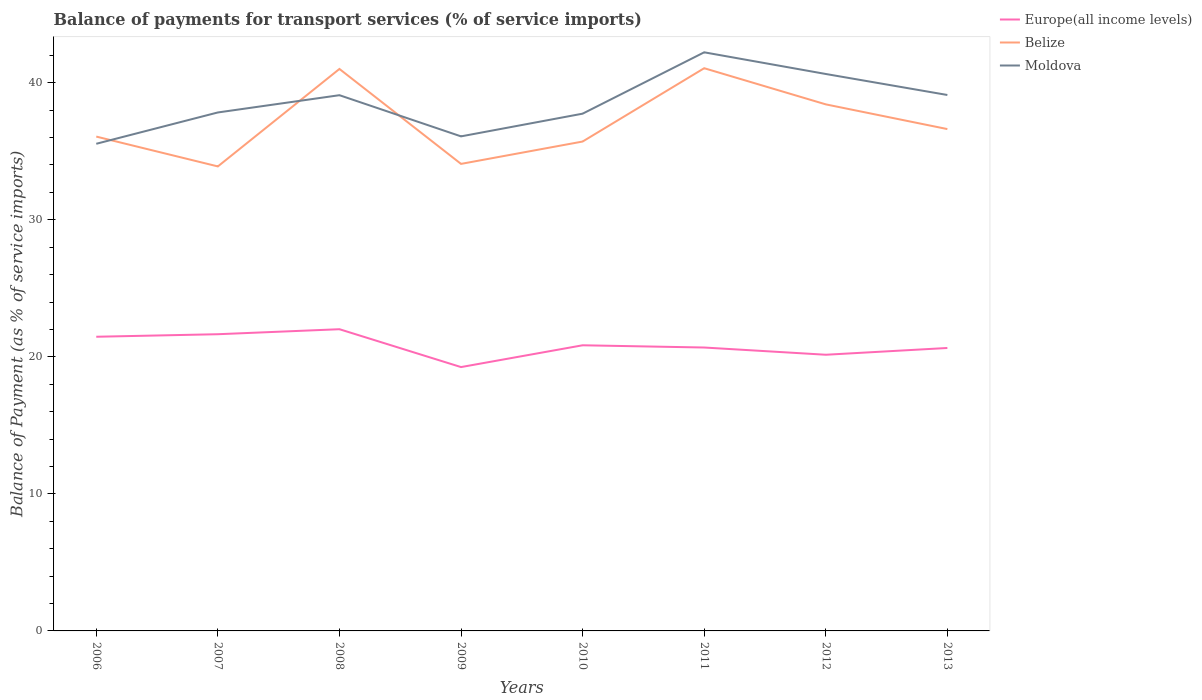How many different coloured lines are there?
Offer a terse response. 3. Is the number of lines equal to the number of legend labels?
Give a very brief answer. Yes. Across all years, what is the maximum balance of payments for transport services in Europe(all income levels)?
Give a very brief answer. 19.25. What is the total balance of payments for transport services in Moldova in the graph?
Your answer should be very brief. -1.55. What is the difference between the highest and the second highest balance of payments for transport services in Belize?
Offer a terse response. 7.17. Is the balance of payments for transport services in Belize strictly greater than the balance of payments for transport services in Europe(all income levels) over the years?
Make the answer very short. No. How many years are there in the graph?
Your answer should be compact. 8. What is the difference between two consecutive major ticks on the Y-axis?
Provide a succinct answer. 10. Does the graph contain grids?
Make the answer very short. No. Where does the legend appear in the graph?
Provide a short and direct response. Top right. How are the legend labels stacked?
Provide a succinct answer. Vertical. What is the title of the graph?
Offer a very short reply. Balance of payments for transport services (% of service imports). Does "St. Martin (French part)" appear as one of the legend labels in the graph?
Ensure brevity in your answer.  No. What is the label or title of the X-axis?
Keep it short and to the point. Years. What is the label or title of the Y-axis?
Provide a short and direct response. Balance of Payment (as % of service imports). What is the Balance of Payment (as % of service imports) of Europe(all income levels) in 2006?
Give a very brief answer. 21.47. What is the Balance of Payment (as % of service imports) of Belize in 2006?
Provide a succinct answer. 36.07. What is the Balance of Payment (as % of service imports) of Moldova in 2006?
Provide a succinct answer. 35.55. What is the Balance of Payment (as % of service imports) of Europe(all income levels) in 2007?
Your answer should be compact. 21.65. What is the Balance of Payment (as % of service imports) of Belize in 2007?
Offer a very short reply. 33.89. What is the Balance of Payment (as % of service imports) in Moldova in 2007?
Your answer should be compact. 37.83. What is the Balance of Payment (as % of service imports) in Europe(all income levels) in 2008?
Provide a succinct answer. 22.02. What is the Balance of Payment (as % of service imports) in Belize in 2008?
Provide a succinct answer. 41.01. What is the Balance of Payment (as % of service imports) of Moldova in 2008?
Your response must be concise. 39.09. What is the Balance of Payment (as % of service imports) in Europe(all income levels) in 2009?
Keep it short and to the point. 19.25. What is the Balance of Payment (as % of service imports) in Belize in 2009?
Make the answer very short. 34.08. What is the Balance of Payment (as % of service imports) of Moldova in 2009?
Your response must be concise. 36.09. What is the Balance of Payment (as % of service imports) in Europe(all income levels) in 2010?
Provide a succinct answer. 20.84. What is the Balance of Payment (as % of service imports) of Belize in 2010?
Offer a terse response. 35.71. What is the Balance of Payment (as % of service imports) in Moldova in 2010?
Offer a very short reply. 37.74. What is the Balance of Payment (as % of service imports) in Europe(all income levels) in 2011?
Give a very brief answer. 20.68. What is the Balance of Payment (as % of service imports) in Belize in 2011?
Your response must be concise. 41.06. What is the Balance of Payment (as % of service imports) of Moldova in 2011?
Offer a terse response. 42.22. What is the Balance of Payment (as % of service imports) in Europe(all income levels) in 2012?
Your response must be concise. 20.15. What is the Balance of Payment (as % of service imports) in Belize in 2012?
Your answer should be very brief. 38.42. What is the Balance of Payment (as % of service imports) in Moldova in 2012?
Ensure brevity in your answer.  40.64. What is the Balance of Payment (as % of service imports) in Europe(all income levels) in 2013?
Your response must be concise. 20.65. What is the Balance of Payment (as % of service imports) of Belize in 2013?
Give a very brief answer. 36.62. What is the Balance of Payment (as % of service imports) of Moldova in 2013?
Offer a very short reply. 39.11. Across all years, what is the maximum Balance of Payment (as % of service imports) in Europe(all income levels)?
Your response must be concise. 22.02. Across all years, what is the maximum Balance of Payment (as % of service imports) of Belize?
Your answer should be compact. 41.06. Across all years, what is the maximum Balance of Payment (as % of service imports) of Moldova?
Your response must be concise. 42.22. Across all years, what is the minimum Balance of Payment (as % of service imports) of Europe(all income levels)?
Your answer should be compact. 19.25. Across all years, what is the minimum Balance of Payment (as % of service imports) in Belize?
Offer a very short reply. 33.89. Across all years, what is the minimum Balance of Payment (as % of service imports) in Moldova?
Your answer should be very brief. 35.55. What is the total Balance of Payment (as % of service imports) of Europe(all income levels) in the graph?
Your answer should be compact. 166.71. What is the total Balance of Payment (as % of service imports) of Belize in the graph?
Make the answer very short. 296.87. What is the total Balance of Payment (as % of service imports) in Moldova in the graph?
Offer a very short reply. 308.28. What is the difference between the Balance of Payment (as % of service imports) in Europe(all income levels) in 2006 and that in 2007?
Offer a very short reply. -0.18. What is the difference between the Balance of Payment (as % of service imports) of Belize in 2006 and that in 2007?
Offer a very short reply. 2.18. What is the difference between the Balance of Payment (as % of service imports) of Moldova in 2006 and that in 2007?
Make the answer very short. -2.29. What is the difference between the Balance of Payment (as % of service imports) of Europe(all income levels) in 2006 and that in 2008?
Offer a terse response. -0.55. What is the difference between the Balance of Payment (as % of service imports) of Belize in 2006 and that in 2008?
Offer a very short reply. -4.93. What is the difference between the Balance of Payment (as % of service imports) in Moldova in 2006 and that in 2008?
Keep it short and to the point. -3.55. What is the difference between the Balance of Payment (as % of service imports) of Europe(all income levels) in 2006 and that in 2009?
Offer a very short reply. 2.21. What is the difference between the Balance of Payment (as % of service imports) in Belize in 2006 and that in 2009?
Offer a terse response. 1.99. What is the difference between the Balance of Payment (as % of service imports) of Moldova in 2006 and that in 2009?
Give a very brief answer. -0.54. What is the difference between the Balance of Payment (as % of service imports) of Europe(all income levels) in 2006 and that in 2010?
Offer a very short reply. 0.62. What is the difference between the Balance of Payment (as % of service imports) in Belize in 2006 and that in 2010?
Provide a short and direct response. 0.36. What is the difference between the Balance of Payment (as % of service imports) in Moldova in 2006 and that in 2010?
Your answer should be very brief. -2.2. What is the difference between the Balance of Payment (as % of service imports) of Europe(all income levels) in 2006 and that in 2011?
Give a very brief answer. 0.79. What is the difference between the Balance of Payment (as % of service imports) of Belize in 2006 and that in 2011?
Your response must be concise. -4.99. What is the difference between the Balance of Payment (as % of service imports) of Moldova in 2006 and that in 2011?
Ensure brevity in your answer.  -6.67. What is the difference between the Balance of Payment (as % of service imports) in Europe(all income levels) in 2006 and that in 2012?
Offer a terse response. 1.31. What is the difference between the Balance of Payment (as % of service imports) of Belize in 2006 and that in 2012?
Your response must be concise. -2.35. What is the difference between the Balance of Payment (as % of service imports) in Moldova in 2006 and that in 2012?
Provide a succinct answer. -5.09. What is the difference between the Balance of Payment (as % of service imports) in Europe(all income levels) in 2006 and that in 2013?
Ensure brevity in your answer.  0.82. What is the difference between the Balance of Payment (as % of service imports) of Belize in 2006 and that in 2013?
Provide a succinct answer. -0.55. What is the difference between the Balance of Payment (as % of service imports) of Moldova in 2006 and that in 2013?
Offer a very short reply. -3.56. What is the difference between the Balance of Payment (as % of service imports) of Europe(all income levels) in 2007 and that in 2008?
Offer a terse response. -0.37. What is the difference between the Balance of Payment (as % of service imports) of Belize in 2007 and that in 2008?
Your answer should be compact. -7.11. What is the difference between the Balance of Payment (as % of service imports) of Moldova in 2007 and that in 2008?
Your answer should be compact. -1.26. What is the difference between the Balance of Payment (as % of service imports) of Europe(all income levels) in 2007 and that in 2009?
Your answer should be very brief. 2.4. What is the difference between the Balance of Payment (as % of service imports) in Belize in 2007 and that in 2009?
Provide a succinct answer. -0.18. What is the difference between the Balance of Payment (as % of service imports) in Moldova in 2007 and that in 2009?
Offer a terse response. 1.74. What is the difference between the Balance of Payment (as % of service imports) in Europe(all income levels) in 2007 and that in 2010?
Your answer should be very brief. 0.81. What is the difference between the Balance of Payment (as % of service imports) in Belize in 2007 and that in 2010?
Make the answer very short. -1.82. What is the difference between the Balance of Payment (as % of service imports) in Moldova in 2007 and that in 2010?
Your response must be concise. 0.09. What is the difference between the Balance of Payment (as % of service imports) in Europe(all income levels) in 2007 and that in 2011?
Offer a very short reply. 0.97. What is the difference between the Balance of Payment (as % of service imports) in Belize in 2007 and that in 2011?
Your answer should be very brief. -7.17. What is the difference between the Balance of Payment (as % of service imports) in Moldova in 2007 and that in 2011?
Your response must be concise. -4.39. What is the difference between the Balance of Payment (as % of service imports) in Europe(all income levels) in 2007 and that in 2012?
Your response must be concise. 1.5. What is the difference between the Balance of Payment (as % of service imports) of Belize in 2007 and that in 2012?
Your answer should be very brief. -4.53. What is the difference between the Balance of Payment (as % of service imports) of Moldova in 2007 and that in 2012?
Provide a short and direct response. -2.81. What is the difference between the Balance of Payment (as % of service imports) of Belize in 2007 and that in 2013?
Your answer should be very brief. -2.73. What is the difference between the Balance of Payment (as % of service imports) in Moldova in 2007 and that in 2013?
Ensure brevity in your answer.  -1.27. What is the difference between the Balance of Payment (as % of service imports) in Europe(all income levels) in 2008 and that in 2009?
Provide a succinct answer. 2.76. What is the difference between the Balance of Payment (as % of service imports) in Belize in 2008 and that in 2009?
Your answer should be compact. 6.93. What is the difference between the Balance of Payment (as % of service imports) in Moldova in 2008 and that in 2009?
Provide a short and direct response. 3. What is the difference between the Balance of Payment (as % of service imports) in Europe(all income levels) in 2008 and that in 2010?
Ensure brevity in your answer.  1.17. What is the difference between the Balance of Payment (as % of service imports) of Belize in 2008 and that in 2010?
Give a very brief answer. 5.3. What is the difference between the Balance of Payment (as % of service imports) of Moldova in 2008 and that in 2010?
Offer a terse response. 1.35. What is the difference between the Balance of Payment (as % of service imports) of Europe(all income levels) in 2008 and that in 2011?
Make the answer very short. 1.34. What is the difference between the Balance of Payment (as % of service imports) in Belize in 2008 and that in 2011?
Keep it short and to the point. -0.05. What is the difference between the Balance of Payment (as % of service imports) of Moldova in 2008 and that in 2011?
Make the answer very short. -3.13. What is the difference between the Balance of Payment (as % of service imports) of Europe(all income levels) in 2008 and that in 2012?
Provide a succinct answer. 1.86. What is the difference between the Balance of Payment (as % of service imports) of Belize in 2008 and that in 2012?
Your answer should be very brief. 2.58. What is the difference between the Balance of Payment (as % of service imports) in Moldova in 2008 and that in 2012?
Ensure brevity in your answer.  -1.55. What is the difference between the Balance of Payment (as % of service imports) in Europe(all income levels) in 2008 and that in 2013?
Keep it short and to the point. 1.37. What is the difference between the Balance of Payment (as % of service imports) in Belize in 2008 and that in 2013?
Give a very brief answer. 4.39. What is the difference between the Balance of Payment (as % of service imports) of Moldova in 2008 and that in 2013?
Your response must be concise. -0.02. What is the difference between the Balance of Payment (as % of service imports) in Europe(all income levels) in 2009 and that in 2010?
Offer a terse response. -1.59. What is the difference between the Balance of Payment (as % of service imports) of Belize in 2009 and that in 2010?
Make the answer very short. -1.63. What is the difference between the Balance of Payment (as % of service imports) of Moldova in 2009 and that in 2010?
Provide a short and direct response. -1.66. What is the difference between the Balance of Payment (as % of service imports) of Europe(all income levels) in 2009 and that in 2011?
Provide a short and direct response. -1.43. What is the difference between the Balance of Payment (as % of service imports) in Belize in 2009 and that in 2011?
Your response must be concise. -6.98. What is the difference between the Balance of Payment (as % of service imports) of Moldova in 2009 and that in 2011?
Your response must be concise. -6.13. What is the difference between the Balance of Payment (as % of service imports) of Europe(all income levels) in 2009 and that in 2012?
Your answer should be compact. -0.9. What is the difference between the Balance of Payment (as % of service imports) of Belize in 2009 and that in 2012?
Provide a short and direct response. -4.34. What is the difference between the Balance of Payment (as % of service imports) in Moldova in 2009 and that in 2012?
Provide a short and direct response. -4.55. What is the difference between the Balance of Payment (as % of service imports) of Europe(all income levels) in 2009 and that in 2013?
Provide a short and direct response. -1.39. What is the difference between the Balance of Payment (as % of service imports) in Belize in 2009 and that in 2013?
Offer a terse response. -2.54. What is the difference between the Balance of Payment (as % of service imports) in Moldova in 2009 and that in 2013?
Provide a succinct answer. -3.02. What is the difference between the Balance of Payment (as % of service imports) of Europe(all income levels) in 2010 and that in 2011?
Provide a short and direct response. 0.16. What is the difference between the Balance of Payment (as % of service imports) of Belize in 2010 and that in 2011?
Ensure brevity in your answer.  -5.35. What is the difference between the Balance of Payment (as % of service imports) of Moldova in 2010 and that in 2011?
Offer a very short reply. -4.48. What is the difference between the Balance of Payment (as % of service imports) of Europe(all income levels) in 2010 and that in 2012?
Give a very brief answer. 0.69. What is the difference between the Balance of Payment (as % of service imports) of Belize in 2010 and that in 2012?
Offer a terse response. -2.71. What is the difference between the Balance of Payment (as % of service imports) of Moldova in 2010 and that in 2012?
Keep it short and to the point. -2.9. What is the difference between the Balance of Payment (as % of service imports) of Europe(all income levels) in 2010 and that in 2013?
Provide a succinct answer. 0.2. What is the difference between the Balance of Payment (as % of service imports) in Belize in 2010 and that in 2013?
Ensure brevity in your answer.  -0.91. What is the difference between the Balance of Payment (as % of service imports) of Moldova in 2010 and that in 2013?
Provide a short and direct response. -1.36. What is the difference between the Balance of Payment (as % of service imports) in Europe(all income levels) in 2011 and that in 2012?
Offer a terse response. 0.53. What is the difference between the Balance of Payment (as % of service imports) in Belize in 2011 and that in 2012?
Your response must be concise. 2.64. What is the difference between the Balance of Payment (as % of service imports) in Moldova in 2011 and that in 2012?
Make the answer very short. 1.58. What is the difference between the Balance of Payment (as % of service imports) of Europe(all income levels) in 2011 and that in 2013?
Provide a short and direct response. 0.03. What is the difference between the Balance of Payment (as % of service imports) in Belize in 2011 and that in 2013?
Give a very brief answer. 4.44. What is the difference between the Balance of Payment (as % of service imports) of Moldova in 2011 and that in 2013?
Make the answer very short. 3.11. What is the difference between the Balance of Payment (as % of service imports) in Europe(all income levels) in 2012 and that in 2013?
Keep it short and to the point. -0.49. What is the difference between the Balance of Payment (as % of service imports) of Belize in 2012 and that in 2013?
Provide a succinct answer. 1.8. What is the difference between the Balance of Payment (as % of service imports) in Moldova in 2012 and that in 2013?
Offer a very short reply. 1.53. What is the difference between the Balance of Payment (as % of service imports) of Europe(all income levels) in 2006 and the Balance of Payment (as % of service imports) of Belize in 2007?
Make the answer very short. -12.43. What is the difference between the Balance of Payment (as % of service imports) in Europe(all income levels) in 2006 and the Balance of Payment (as % of service imports) in Moldova in 2007?
Your answer should be compact. -16.37. What is the difference between the Balance of Payment (as % of service imports) of Belize in 2006 and the Balance of Payment (as % of service imports) of Moldova in 2007?
Your response must be concise. -1.76. What is the difference between the Balance of Payment (as % of service imports) in Europe(all income levels) in 2006 and the Balance of Payment (as % of service imports) in Belize in 2008?
Provide a succinct answer. -19.54. What is the difference between the Balance of Payment (as % of service imports) of Europe(all income levels) in 2006 and the Balance of Payment (as % of service imports) of Moldova in 2008?
Offer a terse response. -17.63. What is the difference between the Balance of Payment (as % of service imports) in Belize in 2006 and the Balance of Payment (as % of service imports) in Moldova in 2008?
Give a very brief answer. -3.02. What is the difference between the Balance of Payment (as % of service imports) of Europe(all income levels) in 2006 and the Balance of Payment (as % of service imports) of Belize in 2009?
Make the answer very short. -12.61. What is the difference between the Balance of Payment (as % of service imports) of Europe(all income levels) in 2006 and the Balance of Payment (as % of service imports) of Moldova in 2009?
Your answer should be compact. -14.62. What is the difference between the Balance of Payment (as % of service imports) of Belize in 2006 and the Balance of Payment (as % of service imports) of Moldova in 2009?
Offer a very short reply. -0.02. What is the difference between the Balance of Payment (as % of service imports) of Europe(all income levels) in 2006 and the Balance of Payment (as % of service imports) of Belize in 2010?
Ensure brevity in your answer.  -14.25. What is the difference between the Balance of Payment (as % of service imports) of Europe(all income levels) in 2006 and the Balance of Payment (as % of service imports) of Moldova in 2010?
Your response must be concise. -16.28. What is the difference between the Balance of Payment (as % of service imports) in Belize in 2006 and the Balance of Payment (as % of service imports) in Moldova in 2010?
Ensure brevity in your answer.  -1.67. What is the difference between the Balance of Payment (as % of service imports) of Europe(all income levels) in 2006 and the Balance of Payment (as % of service imports) of Belize in 2011?
Give a very brief answer. -19.6. What is the difference between the Balance of Payment (as % of service imports) of Europe(all income levels) in 2006 and the Balance of Payment (as % of service imports) of Moldova in 2011?
Your answer should be very brief. -20.76. What is the difference between the Balance of Payment (as % of service imports) in Belize in 2006 and the Balance of Payment (as % of service imports) in Moldova in 2011?
Your answer should be very brief. -6.15. What is the difference between the Balance of Payment (as % of service imports) in Europe(all income levels) in 2006 and the Balance of Payment (as % of service imports) in Belize in 2012?
Your response must be concise. -16.96. What is the difference between the Balance of Payment (as % of service imports) of Europe(all income levels) in 2006 and the Balance of Payment (as % of service imports) of Moldova in 2012?
Ensure brevity in your answer.  -19.17. What is the difference between the Balance of Payment (as % of service imports) in Belize in 2006 and the Balance of Payment (as % of service imports) in Moldova in 2012?
Your answer should be very brief. -4.57. What is the difference between the Balance of Payment (as % of service imports) of Europe(all income levels) in 2006 and the Balance of Payment (as % of service imports) of Belize in 2013?
Keep it short and to the point. -15.15. What is the difference between the Balance of Payment (as % of service imports) of Europe(all income levels) in 2006 and the Balance of Payment (as % of service imports) of Moldova in 2013?
Provide a short and direct response. -17.64. What is the difference between the Balance of Payment (as % of service imports) of Belize in 2006 and the Balance of Payment (as % of service imports) of Moldova in 2013?
Provide a succinct answer. -3.04. What is the difference between the Balance of Payment (as % of service imports) of Europe(all income levels) in 2007 and the Balance of Payment (as % of service imports) of Belize in 2008?
Your response must be concise. -19.36. What is the difference between the Balance of Payment (as % of service imports) in Europe(all income levels) in 2007 and the Balance of Payment (as % of service imports) in Moldova in 2008?
Offer a very short reply. -17.44. What is the difference between the Balance of Payment (as % of service imports) in Belize in 2007 and the Balance of Payment (as % of service imports) in Moldova in 2008?
Ensure brevity in your answer.  -5.2. What is the difference between the Balance of Payment (as % of service imports) of Europe(all income levels) in 2007 and the Balance of Payment (as % of service imports) of Belize in 2009?
Provide a succinct answer. -12.43. What is the difference between the Balance of Payment (as % of service imports) of Europe(all income levels) in 2007 and the Balance of Payment (as % of service imports) of Moldova in 2009?
Provide a succinct answer. -14.44. What is the difference between the Balance of Payment (as % of service imports) in Belize in 2007 and the Balance of Payment (as % of service imports) in Moldova in 2009?
Offer a very short reply. -2.19. What is the difference between the Balance of Payment (as % of service imports) of Europe(all income levels) in 2007 and the Balance of Payment (as % of service imports) of Belize in 2010?
Make the answer very short. -14.06. What is the difference between the Balance of Payment (as % of service imports) in Europe(all income levels) in 2007 and the Balance of Payment (as % of service imports) in Moldova in 2010?
Make the answer very short. -16.09. What is the difference between the Balance of Payment (as % of service imports) in Belize in 2007 and the Balance of Payment (as % of service imports) in Moldova in 2010?
Keep it short and to the point. -3.85. What is the difference between the Balance of Payment (as % of service imports) in Europe(all income levels) in 2007 and the Balance of Payment (as % of service imports) in Belize in 2011?
Your answer should be very brief. -19.41. What is the difference between the Balance of Payment (as % of service imports) in Europe(all income levels) in 2007 and the Balance of Payment (as % of service imports) in Moldova in 2011?
Keep it short and to the point. -20.57. What is the difference between the Balance of Payment (as % of service imports) of Belize in 2007 and the Balance of Payment (as % of service imports) of Moldova in 2011?
Make the answer very short. -8.33. What is the difference between the Balance of Payment (as % of service imports) in Europe(all income levels) in 2007 and the Balance of Payment (as % of service imports) in Belize in 2012?
Your answer should be compact. -16.77. What is the difference between the Balance of Payment (as % of service imports) of Europe(all income levels) in 2007 and the Balance of Payment (as % of service imports) of Moldova in 2012?
Your answer should be very brief. -18.99. What is the difference between the Balance of Payment (as % of service imports) of Belize in 2007 and the Balance of Payment (as % of service imports) of Moldova in 2012?
Offer a terse response. -6.75. What is the difference between the Balance of Payment (as % of service imports) of Europe(all income levels) in 2007 and the Balance of Payment (as % of service imports) of Belize in 2013?
Your answer should be compact. -14.97. What is the difference between the Balance of Payment (as % of service imports) in Europe(all income levels) in 2007 and the Balance of Payment (as % of service imports) in Moldova in 2013?
Provide a succinct answer. -17.46. What is the difference between the Balance of Payment (as % of service imports) of Belize in 2007 and the Balance of Payment (as % of service imports) of Moldova in 2013?
Your answer should be compact. -5.21. What is the difference between the Balance of Payment (as % of service imports) of Europe(all income levels) in 2008 and the Balance of Payment (as % of service imports) of Belize in 2009?
Provide a short and direct response. -12.06. What is the difference between the Balance of Payment (as % of service imports) of Europe(all income levels) in 2008 and the Balance of Payment (as % of service imports) of Moldova in 2009?
Make the answer very short. -14.07. What is the difference between the Balance of Payment (as % of service imports) of Belize in 2008 and the Balance of Payment (as % of service imports) of Moldova in 2009?
Offer a very short reply. 4.92. What is the difference between the Balance of Payment (as % of service imports) in Europe(all income levels) in 2008 and the Balance of Payment (as % of service imports) in Belize in 2010?
Offer a very short reply. -13.69. What is the difference between the Balance of Payment (as % of service imports) in Europe(all income levels) in 2008 and the Balance of Payment (as % of service imports) in Moldova in 2010?
Give a very brief answer. -15.73. What is the difference between the Balance of Payment (as % of service imports) of Belize in 2008 and the Balance of Payment (as % of service imports) of Moldova in 2010?
Ensure brevity in your answer.  3.26. What is the difference between the Balance of Payment (as % of service imports) of Europe(all income levels) in 2008 and the Balance of Payment (as % of service imports) of Belize in 2011?
Provide a succinct answer. -19.05. What is the difference between the Balance of Payment (as % of service imports) in Europe(all income levels) in 2008 and the Balance of Payment (as % of service imports) in Moldova in 2011?
Provide a succinct answer. -20.21. What is the difference between the Balance of Payment (as % of service imports) of Belize in 2008 and the Balance of Payment (as % of service imports) of Moldova in 2011?
Your answer should be very brief. -1.21. What is the difference between the Balance of Payment (as % of service imports) in Europe(all income levels) in 2008 and the Balance of Payment (as % of service imports) in Belize in 2012?
Provide a short and direct response. -16.41. What is the difference between the Balance of Payment (as % of service imports) of Europe(all income levels) in 2008 and the Balance of Payment (as % of service imports) of Moldova in 2012?
Your answer should be very brief. -18.62. What is the difference between the Balance of Payment (as % of service imports) of Belize in 2008 and the Balance of Payment (as % of service imports) of Moldova in 2012?
Your response must be concise. 0.37. What is the difference between the Balance of Payment (as % of service imports) of Europe(all income levels) in 2008 and the Balance of Payment (as % of service imports) of Belize in 2013?
Ensure brevity in your answer.  -14.6. What is the difference between the Balance of Payment (as % of service imports) of Europe(all income levels) in 2008 and the Balance of Payment (as % of service imports) of Moldova in 2013?
Your response must be concise. -17.09. What is the difference between the Balance of Payment (as % of service imports) of Belize in 2008 and the Balance of Payment (as % of service imports) of Moldova in 2013?
Offer a very short reply. 1.9. What is the difference between the Balance of Payment (as % of service imports) in Europe(all income levels) in 2009 and the Balance of Payment (as % of service imports) in Belize in 2010?
Your response must be concise. -16.46. What is the difference between the Balance of Payment (as % of service imports) of Europe(all income levels) in 2009 and the Balance of Payment (as % of service imports) of Moldova in 2010?
Ensure brevity in your answer.  -18.49. What is the difference between the Balance of Payment (as % of service imports) of Belize in 2009 and the Balance of Payment (as % of service imports) of Moldova in 2010?
Your answer should be very brief. -3.66. What is the difference between the Balance of Payment (as % of service imports) of Europe(all income levels) in 2009 and the Balance of Payment (as % of service imports) of Belize in 2011?
Give a very brief answer. -21.81. What is the difference between the Balance of Payment (as % of service imports) of Europe(all income levels) in 2009 and the Balance of Payment (as % of service imports) of Moldova in 2011?
Your answer should be very brief. -22.97. What is the difference between the Balance of Payment (as % of service imports) in Belize in 2009 and the Balance of Payment (as % of service imports) in Moldova in 2011?
Your response must be concise. -8.14. What is the difference between the Balance of Payment (as % of service imports) in Europe(all income levels) in 2009 and the Balance of Payment (as % of service imports) in Belize in 2012?
Offer a terse response. -19.17. What is the difference between the Balance of Payment (as % of service imports) of Europe(all income levels) in 2009 and the Balance of Payment (as % of service imports) of Moldova in 2012?
Your answer should be compact. -21.39. What is the difference between the Balance of Payment (as % of service imports) of Belize in 2009 and the Balance of Payment (as % of service imports) of Moldova in 2012?
Provide a succinct answer. -6.56. What is the difference between the Balance of Payment (as % of service imports) of Europe(all income levels) in 2009 and the Balance of Payment (as % of service imports) of Belize in 2013?
Ensure brevity in your answer.  -17.37. What is the difference between the Balance of Payment (as % of service imports) of Europe(all income levels) in 2009 and the Balance of Payment (as % of service imports) of Moldova in 2013?
Your answer should be very brief. -19.86. What is the difference between the Balance of Payment (as % of service imports) in Belize in 2009 and the Balance of Payment (as % of service imports) in Moldova in 2013?
Ensure brevity in your answer.  -5.03. What is the difference between the Balance of Payment (as % of service imports) in Europe(all income levels) in 2010 and the Balance of Payment (as % of service imports) in Belize in 2011?
Offer a very short reply. -20.22. What is the difference between the Balance of Payment (as % of service imports) of Europe(all income levels) in 2010 and the Balance of Payment (as % of service imports) of Moldova in 2011?
Your response must be concise. -21.38. What is the difference between the Balance of Payment (as % of service imports) in Belize in 2010 and the Balance of Payment (as % of service imports) in Moldova in 2011?
Make the answer very short. -6.51. What is the difference between the Balance of Payment (as % of service imports) of Europe(all income levels) in 2010 and the Balance of Payment (as % of service imports) of Belize in 2012?
Your answer should be compact. -17.58. What is the difference between the Balance of Payment (as % of service imports) in Europe(all income levels) in 2010 and the Balance of Payment (as % of service imports) in Moldova in 2012?
Your answer should be very brief. -19.8. What is the difference between the Balance of Payment (as % of service imports) of Belize in 2010 and the Balance of Payment (as % of service imports) of Moldova in 2012?
Provide a short and direct response. -4.93. What is the difference between the Balance of Payment (as % of service imports) in Europe(all income levels) in 2010 and the Balance of Payment (as % of service imports) in Belize in 2013?
Offer a terse response. -15.78. What is the difference between the Balance of Payment (as % of service imports) in Europe(all income levels) in 2010 and the Balance of Payment (as % of service imports) in Moldova in 2013?
Keep it short and to the point. -18.26. What is the difference between the Balance of Payment (as % of service imports) of Belize in 2010 and the Balance of Payment (as % of service imports) of Moldova in 2013?
Keep it short and to the point. -3.4. What is the difference between the Balance of Payment (as % of service imports) in Europe(all income levels) in 2011 and the Balance of Payment (as % of service imports) in Belize in 2012?
Your answer should be very brief. -17.74. What is the difference between the Balance of Payment (as % of service imports) of Europe(all income levels) in 2011 and the Balance of Payment (as % of service imports) of Moldova in 2012?
Provide a succinct answer. -19.96. What is the difference between the Balance of Payment (as % of service imports) of Belize in 2011 and the Balance of Payment (as % of service imports) of Moldova in 2012?
Keep it short and to the point. 0.42. What is the difference between the Balance of Payment (as % of service imports) in Europe(all income levels) in 2011 and the Balance of Payment (as % of service imports) in Belize in 2013?
Provide a succinct answer. -15.94. What is the difference between the Balance of Payment (as % of service imports) of Europe(all income levels) in 2011 and the Balance of Payment (as % of service imports) of Moldova in 2013?
Make the answer very short. -18.43. What is the difference between the Balance of Payment (as % of service imports) of Belize in 2011 and the Balance of Payment (as % of service imports) of Moldova in 2013?
Your answer should be compact. 1.95. What is the difference between the Balance of Payment (as % of service imports) in Europe(all income levels) in 2012 and the Balance of Payment (as % of service imports) in Belize in 2013?
Your answer should be very brief. -16.47. What is the difference between the Balance of Payment (as % of service imports) in Europe(all income levels) in 2012 and the Balance of Payment (as % of service imports) in Moldova in 2013?
Provide a succinct answer. -18.95. What is the difference between the Balance of Payment (as % of service imports) of Belize in 2012 and the Balance of Payment (as % of service imports) of Moldova in 2013?
Offer a very short reply. -0.69. What is the average Balance of Payment (as % of service imports) of Europe(all income levels) per year?
Keep it short and to the point. 20.84. What is the average Balance of Payment (as % of service imports) in Belize per year?
Your response must be concise. 37.11. What is the average Balance of Payment (as % of service imports) in Moldova per year?
Your answer should be very brief. 38.53. In the year 2006, what is the difference between the Balance of Payment (as % of service imports) in Europe(all income levels) and Balance of Payment (as % of service imports) in Belize?
Offer a very short reply. -14.61. In the year 2006, what is the difference between the Balance of Payment (as % of service imports) of Europe(all income levels) and Balance of Payment (as % of service imports) of Moldova?
Keep it short and to the point. -14.08. In the year 2006, what is the difference between the Balance of Payment (as % of service imports) in Belize and Balance of Payment (as % of service imports) in Moldova?
Provide a short and direct response. 0.53. In the year 2007, what is the difference between the Balance of Payment (as % of service imports) of Europe(all income levels) and Balance of Payment (as % of service imports) of Belize?
Your response must be concise. -12.24. In the year 2007, what is the difference between the Balance of Payment (as % of service imports) of Europe(all income levels) and Balance of Payment (as % of service imports) of Moldova?
Provide a short and direct response. -16.18. In the year 2007, what is the difference between the Balance of Payment (as % of service imports) of Belize and Balance of Payment (as % of service imports) of Moldova?
Give a very brief answer. -3.94. In the year 2008, what is the difference between the Balance of Payment (as % of service imports) in Europe(all income levels) and Balance of Payment (as % of service imports) in Belize?
Provide a short and direct response. -18.99. In the year 2008, what is the difference between the Balance of Payment (as % of service imports) in Europe(all income levels) and Balance of Payment (as % of service imports) in Moldova?
Provide a succinct answer. -17.08. In the year 2008, what is the difference between the Balance of Payment (as % of service imports) in Belize and Balance of Payment (as % of service imports) in Moldova?
Offer a terse response. 1.91. In the year 2009, what is the difference between the Balance of Payment (as % of service imports) in Europe(all income levels) and Balance of Payment (as % of service imports) in Belize?
Ensure brevity in your answer.  -14.83. In the year 2009, what is the difference between the Balance of Payment (as % of service imports) of Europe(all income levels) and Balance of Payment (as % of service imports) of Moldova?
Your answer should be compact. -16.84. In the year 2009, what is the difference between the Balance of Payment (as % of service imports) in Belize and Balance of Payment (as % of service imports) in Moldova?
Give a very brief answer. -2.01. In the year 2010, what is the difference between the Balance of Payment (as % of service imports) in Europe(all income levels) and Balance of Payment (as % of service imports) in Belize?
Offer a very short reply. -14.87. In the year 2010, what is the difference between the Balance of Payment (as % of service imports) of Europe(all income levels) and Balance of Payment (as % of service imports) of Moldova?
Keep it short and to the point. -16.9. In the year 2010, what is the difference between the Balance of Payment (as % of service imports) in Belize and Balance of Payment (as % of service imports) in Moldova?
Your answer should be compact. -2.03. In the year 2011, what is the difference between the Balance of Payment (as % of service imports) of Europe(all income levels) and Balance of Payment (as % of service imports) of Belize?
Your answer should be compact. -20.38. In the year 2011, what is the difference between the Balance of Payment (as % of service imports) of Europe(all income levels) and Balance of Payment (as % of service imports) of Moldova?
Offer a very short reply. -21.54. In the year 2011, what is the difference between the Balance of Payment (as % of service imports) of Belize and Balance of Payment (as % of service imports) of Moldova?
Your answer should be compact. -1.16. In the year 2012, what is the difference between the Balance of Payment (as % of service imports) in Europe(all income levels) and Balance of Payment (as % of service imports) in Belize?
Provide a short and direct response. -18.27. In the year 2012, what is the difference between the Balance of Payment (as % of service imports) of Europe(all income levels) and Balance of Payment (as % of service imports) of Moldova?
Ensure brevity in your answer.  -20.49. In the year 2012, what is the difference between the Balance of Payment (as % of service imports) of Belize and Balance of Payment (as % of service imports) of Moldova?
Give a very brief answer. -2.22. In the year 2013, what is the difference between the Balance of Payment (as % of service imports) in Europe(all income levels) and Balance of Payment (as % of service imports) in Belize?
Keep it short and to the point. -15.97. In the year 2013, what is the difference between the Balance of Payment (as % of service imports) of Europe(all income levels) and Balance of Payment (as % of service imports) of Moldova?
Your response must be concise. -18.46. In the year 2013, what is the difference between the Balance of Payment (as % of service imports) of Belize and Balance of Payment (as % of service imports) of Moldova?
Ensure brevity in your answer.  -2.49. What is the ratio of the Balance of Payment (as % of service imports) of Europe(all income levels) in 2006 to that in 2007?
Offer a terse response. 0.99. What is the ratio of the Balance of Payment (as % of service imports) of Belize in 2006 to that in 2007?
Give a very brief answer. 1.06. What is the ratio of the Balance of Payment (as % of service imports) of Moldova in 2006 to that in 2007?
Provide a short and direct response. 0.94. What is the ratio of the Balance of Payment (as % of service imports) of Belize in 2006 to that in 2008?
Provide a short and direct response. 0.88. What is the ratio of the Balance of Payment (as % of service imports) of Moldova in 2006 to that in 2008?
Your answer should be very brief. 0.91. What is the ratio of the Balance of Payment (as % of service imports) in Europe(all income levels) in 2006 to that in 2009?
Provide a succinct answer. 1.11. What is the ratio of the Balance of Payment (as % of service imports) in Belize in 2006 to that in 2009?
Keep it short and to the point. 1.06. What is the ratio of the Balance of Payment (as % of service imports) of Europe(all income levels) in 2006 to that in 2010?
Provide a short and direct response. 1.03. What is the ratio of the Balance of Payment (as % of service imports) of Belize in 2006 to that in 2010?
Give a very brief answer. 1.01. What is the ratio of the Balance of Payment (as % of service imports) of Moldova in 2006 to that in 2010?
Your answer should be compact. 0.94. What is the ratio of the Balance of Payment (as % of service imports) of Europe(all income levels) in 2006 to that in 2011?
Your response must be concise. 1.04. What is the ratio of the Balance of Payment (as % of service imports) of Belize in 2006 to that in 2011?
Your answer should be compact. 0.88. What is the ratio of the Balance of Payment (as % of service imports) in Moldova in 2006 to that in 2011?
Offer a terse response. 0.84. What is the ratio of the Balance of Payment (as % of service imports) in Europe(all income levels) in 2006 to that in 2012?
Keep it short and to the point. 1.07. What is the ratio of the Balance of Payment (as % of service imports) in Belize in 2006 to that in 2012?
Offer a very short reply. 0.94. What is the ratio of the Balance of Payment (as % of service imports) in Moldova in 2006 to that in 2012?
Offer a very short reply. 0.87. What is the ratio of the Balance of Payment (as % of service imports) of Europe(all income levels) in 2006 to that in 2013?
Keep it short and to the point. 1.04. What is the ratio of the Balance of Payment (as % of service imports) in Moldova in 2006 to that in 2013?
Offer a terse response. 0.91. What is the ratio of the Balance of Payment (as % of service imports) of Europe(all income levels) in 2007 to that in 2008?
Keep it short and to the point. 0.98. What is the ratio of the Balance of Payment (as % of service imports) in Belize in 2007 to that in 2008?
Provide a short and direct response. 0.83. What is the ratio of the Balance of Payment (as % of service imports) in Moldova in 2007 to that in 2008?
Ensure brevity in your answer.  0.97. What is the ratio of the Balance of Payment (as % of service imports) in Europe(all income levels) in 2007 to that in 2009?
Provide a short and direct response. 1.12. What is the ratio of the Balance of Payment (as % of service imports) of Belize in 2007 to that in 2009?
Keep it short and to the point. 0.99. What is the ratio of the Balance of Payment (as % of service imports) of Moldova in 2007 to that in 2009?
Ensure brevity in your answer.  1.05. What is the ratio of the Balance of Payment (as % of service imports) of Europe(all income levels) in 2007 to that in 2010?
Provide a succinct answer. 1.04. What is the ratio of the Balance of Payment (as % of service imports) of Belize in 2007 to that in 2010?
Provide a succinct answer. 0.95. What is the ratio of the Balance of Payment (as % of service imports) in Moldova in 2007 to that in 2010?
Your answer should be compact. 1. What is the ratio of the Balance of Payment (as % of service imports) in Europe(all income levels) in 2007 to that in 2011?
Provide a succinct answer. 1.05. What is the ratio of the Balance of Payment (as % of service imports) in Belize in 2007 to that in 2011?
Offer a very short reply. 0.83. What is the ratio of the Balance of Payment (as % of service imports) in Moldova in 2007 to that in 2011?
Make the answer very short. 0.9. What is the ratio of the Balance of Payment (as % of service imports) in Europe(all income levels) in 2007 to that in 2012?
Your answer should be compact. 1.07. What is the ratio of the Balance of Payment (as % of service imports) in Belize in 2007 to that in 2012?
Your response must be concise. 0.88. What is the ratio of the Balance of Payment (as % of service imports) of Moldova in 2007 to that in 2012?
Provide a succinct answer. 0.93. What is the ratio of the Balance of Payment (as % of service imports) in Europe(all income levels) in 2007 to that in 2013?
Give a very brief answer. 1.05. What is the ratio of the Balance of Payment (as % of service imports) of Belize in 2007 to that in 2013?
Give a very brief answer. 0.93. What is the ratio of the Balance of Payment (as % of service imports) in Moldova in 2007 to that in 2013?
Provide a succinct answer. 0.97. What is the ratio of the Balance of Payment (as % of service imports) of Europe(all income levels) in 2008 to that in 2009?
Your answer should be very brief. 1.14. What is the ratio of the Balance of Payment (as % of service imports) in Belize in 2008 to that in 2009?
Ensure brevity in your answer.  1.2. What is the ratio of the Balance of Payment (as % of service imports) of Moldova in 2008 to that in 2009?
Give a very brief answer. 1.08. What is the ratio of the Balance of Payment (as % of service imports) in Europe(all income levels) in 2008 to that in 2010?
Your response must be concise. 1.06. What is the ratio of the Balance of Payment (as % of service imports) in Belize in 2008 to that in 2010?
Provide a short and direct response. 1.15. What is the ratio of the Balance of Payment (as % of service imports) in Moldova in 2008 to that in 2010?
Give a very brief answer. 1.04. What is the ratio of the Balance of Payment (as % of service imports) of Europe(all income levels) in 2008 to that in 2011?
Your response must be concise. 1.06. What is the ratio of the Balance of Payment (as % of service imports) in Moldova in 2008 to that in 2011?
Keep it short and to the point. 0.93. What is the ratio of the Balance of Payment (as % of service imports) in Europe(all income levels) in 2008 to that in 2012?
Keep it short and to the point. 1.09. What is the ratio of the Balance of Payment (as % of service imports) of Belize in 2008 to that in 2012?
Make the answer very short. 1.07. What is the ratio of the Balance of Payment (as % of service imports) in Moldova in 2008 to that in 2012?
Your response must be concise. 0.96. What is the ratio of the Balance of Payment (as % of service imports) of Europe(all income levels) in 2008 to that in 2013?
Ensure brevity in your answer.  1.07. What is the ratio of the Balance of Payment (as % of service imports) in Belize in 2008 to that in 2013?
Provide a succinct answer. 1.12. What is the ratio of the Balance of Payment (as % of service imports) of Moldova in 2008 to that in 2013?
Offer a very short reply. 1. What is the ratio of the Balance of Payment (as % of service imports) in Europe(all income levels) in 2009 to that in 2010?
Ensure brevity in your answer.  0.92. What is the ratio of the Balance of Payment (as % of service imports) of Belize in 2009 to that in 2010?
Your response must be concise. 0.95. What is the ratio of the Balance of Payment (as % of service imports) of Moldova in 2009 to that in 2010?
Offer a terse response. 0.96. What is the ratio of the Balance of Payment (as % of service imports) of Europe(all income levels) in 2009 to that in 2011?
Provide a short and direct response. 0.93. What is the ratio of the Balance of Payment (as % of service imports) of Belize in 2009 to that in 2011?
Provide a succinct answer. 0.83. What is the ratio of the Balance of Payment (as % of service imports) of Moldova in 2009 to that in 2011?
Provide a short and direct response. 0.85. What is the ratio of the Balance of Payment (as % of service imports) in Europe(all income levels) in 2009 to that in 2012?
Provide a succinct answer. 0.96. What is the ratio of the Balance of Payment (as % of service imports) in Belize in 2009 to that in 2012?
Offer a very short reply. 0.89. What is the ratio of the Balance of Payment (as % of service imports) of Moldova in 2009 to that in 2012?
Keep it short and to the point. 0.89. What is the ratio of the Balance of Payment (as % of service imports) in Europe(all income levels) in 2009 to that in 2013?
Give a very brief answer. 0.93. What is the ratio of the Balance of Payment (as % of service imports) in Belize in 2009 to that in 2013?
Your answer should be compact. 0.93. What is the ratio of the Balance of Payment (as % of service imports) in Moldova in 2009 to that in 2013?
Offer a terse response. 0.92. What is the ratio of the Balance of Payment (as % of service imports) in Europe(all income levels) in 2010 to that in 2011?
Keep it short and to the point. 1.01. What is the ratio of the Balance of Payment (as % of service imports) in Belize in 2010 to that in 2011?
Provide a succinct answer. 0.87. What is the ratio of the Balance of Payment (as % of service imports) in Moldova in 2010 to that in 2011?
Provide a short and direct response. 0.89. What is the ratio of the Balance of Payment (as % of service imports) of Europe(all income levels) in 2010 to that in 2012?
Give a very brief answer. 1.03. What is the ratio of the Balance of Payment (as % of service imports) in Belize in 2010 to that in 2012?
Offer a terse response. 0.93. What is the ratio of the Balance of Payment (as % of service imports) of Moldova in 2010 to that in 2012?
Your answer should be very brief. 0.93. What is the ratio of the Balance of Payment (as % of service imports) in Europe(all income levels) in 2010 to that in 2013?
Offer a very short reply. 1.01. What is the ratio of the Balance of Payment (as % of service imports) in Belize in 2010 to that in 2013?
Your response must be concise. 0.98. What is the ratio of the Balance of Payment (as % of service imports) in Moldova in 2010 to that in 2013?
Provide a short and direct response. 0.97. What is the ratio of the Balance of Payment (as % of service imports) in Europe(all income levels) in 2011 to that in 2012?
Provide a succinct answer. 1.03. What is the ratio of the Balance of Payment (as % of service imports) in Belize in 2011 to that in 2012?
Your answer should be compact. 1.07. What is the ratio of the Balance of Payment (as % of service imports) of Moldova in 2011 to that in 2012?
Give a very brief answer. 1.04. What is the ratio of the Balance of Payment (as % of service imports) of Europe(all income levels) in 2011 to that in 2013?
Provide a short and direct response. 1. What is the ratio of the Balance of Payment (as % of service imports) of Belize in 2011 to that in 2013?
Your answer should be very brief. 1.12. What is the ratio of the Balance of Payment (as % of service imports) of Moldova in 2011 to that in 2013?
Keep it short and to the point. 1.08. What is the ratio of the Balance of Payment (as % of service imports) of Europe(all income levels) in 2012 to that in 2013?
Keep it short and to the point. 0.98. What is the ratio of the Balance of Payment (as % of service imports) of Belize in 2012 to that in 2013?
Keep it short and to the point. 1.05. What is the ratio of the Balance of Payment (as % of service imports) in Moldova in 2012 to that in 2013?
Keep it short and to the point. 1.04. What is the difference between the highest and the second highest Balance of Payment (as % of service imports) of Europe(all income levels)?
Your answer should be very brief. 0.37. What is the difference between the highest and the second highest Balance of Payment (as % of service imports) in Belize?
Provide a succinct answer. 0.05. What is the difference between the highest and the second highest Balance of Payment (as % of service imports) of Moldova?
Make the answer very short. 1.58. What is the difference between the highest and the lowest Balance of Payment (as % of service imports) in Europe(all income levels)?
Ensure brevity in your answer.  2.76. What is the difference between the highest and the lowest Balance of Payment (as % of service imports) of Belize?
Make the answer very short. 7.17. What is the difference between the highest and the lowest Balance of Payment (as % of service imports) in Moldova?
Offer a very short reply. 6.67. 